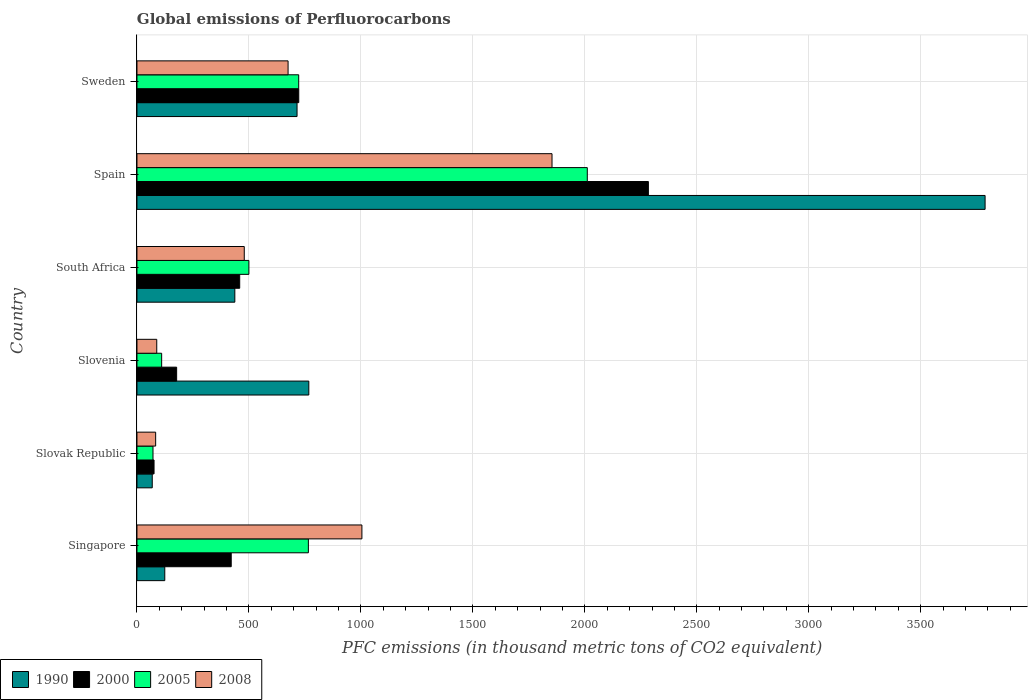How many groups of bars are there?
Give a very brief answer. 6. Are the number of bars per tick equal to the number of legend labels?
Make the answer very short. Yes. What is the global emissions of Perfluorocarbons in 2005 in Slovenia?
Ensure brevity in your answer.  110.3. Across all countries, what is the maximum global emissions of Perfluorocarbons in 2000?
Offer a terse response. 2283.8. Across all countries, what is the minimum global emissions of Perfluorocarbons in 2008?
Your answer should be compact. 83.5. In which country was the global emissions of Perfluorocarbons in 2008 maximum?
Offer a terse response. Spain. In which country was the global emissions of Perfluorocarbons in 1990 minimum?
Your answer should be very brief. Slovak Republic. What is the total global emissions of Perfluorocarbons in 2005 in the graph?
Ensure brevity in your answer.  4180.5. What is the difference between the global emissions of Perfluorocarbons in 1990 in Slovak Republic and that in South Africa?
Your response must be concise. -368.7. What is the difference between the global emissions of Perfluorocarbons in 1990 in Sweden and the global emissions of Perfluorocarbons in 2008 in South Africa?
Give a very brief answer. 235.7. What is the average global emissions of Perfluorocarbons in 2005 per country?
Provide a succinct answer. 696.75. What is the difference between the global emissions of Perfluorocarbons in 2008 and global emissions of Perfluorocarbons in 2000 in Sweden?
Make the answer very short. -47.7. What is the ratio of the global emissions of Perfluorocarbons in 2000 in Slovak Republic to that in Slovenia?
Offer a very short reply. 0.43. Is the difference between the global emissions of Perfluorocarbons in 2008 in Singapore and Slovak Republic greater than the difference between the global emissions of Perfluorocarbons in 2000 in Singapore and Slovak Republic?
Keep it short and to the point. Yes. What is the difference between the highest and the second highest global emissions of Perfluorocarbons in 2005?
Provide a succinct answer. 1245.5. What is the difference between the highest and the lowest global emissions of Perfluorocarbons in 1990?
Your response must be concise. 3719.1. What does the 2nd bar from the top in South Africa represents?
Provide a succinct answer. 2005. What does the 1st bar from the bottom in Singapore represents?
Your response must be concise. 1990. Are the values on the major ticks of X-axis written in scientific E-notation?
Ensure brevity in your answer.  No. Does the graph contain any zero values?
Provide a short and direct response. No. What is the title of the graph?
Your response must be concise. Global emissions of Perfluorocarbons. What is the label or title of the X-axis?
Offer a terse response. PFC emissions (in thousand metric tons of CO2 equivalent). What is the label or title of the Y-axis?
Your answer should be very brief. Country. What is the PFC emissions (in thousand metric tons of CO2 equivalent) of 1990 in Singapore?
Make the answer very short. 124.2. What is the PFC emissions (in thousand metric tons of CO2 equivalent) in 2000 in Singapore?
Keep it short and to the point. 420.9. What is the PFC emissions (in thousand metric tons of CO2 equivalent) of 2005 in Singapore?
Your answer should be compact. 765.5. What is the PFC emissions (in thousand metric tons of CO2 equivalent) of 2008 in Singapore?
Provide a succinct answer. 1004.5. What is the PFC emissions (in thousand metric tons of CO2 equivalent) of 1990 in Slovak Republic?
Your answer should be very brief. 68.3. What is the PFC emissions (in thousand metric tons of CO2 equivalent) in 2000 in Slovak Republic?
Your response must be concise. 76.3. What is the PFC emissions (in thousand metric tons of CO2 equivalent) of 2005 in Slovak Republic?
Your response must be concise. 71.6. What is the PFC emissions (in thousand metric tons of CO2 equivalent) in 2008 in Slovak Republic?
Your answer should be very brief. 83.5. What is the PFC emissions (in thousand metric tons of CO2 equivalent) of 1990 in Slovenia?
Provide a short and direct response. 767.4. What is the PFC emissions (in thousand metric tons of CO2 equivalent) in 2000 in Slovenia?
Your answer should be very brief. 177.2. What is the PFC emissions (in thousand metric tons of CO2 equivalent) of 2005 in Slovenia?
Your answer should be compact. 110.3. What is the PFC emissions (in thousand metric tons of CO2 equivalent) in 2008 in Slovenia?
Provide a short and direct response. 88.4. What is the PFC emissions (in thousand metric tons of CO2 equivalent) of 1990 in South Africa?
Ensure brevity in your answer.  437. What is the PFC emissions (in thousand metric tons of CO2 equivalent) in 2000 in South Africa?
Provide a short and direct response. 458.8. What is the PFC emissions (in thousand metric tons of CO2 equivalent) in 2005 in South Africa?
Make the answer very short. 499.8. What is the PFC emissions (in thousand metric tons of CO2 equivalent) in 2008 in South Africa?
Offer a terse response. 479.2. What is the PFC emissions (in thousand metric tons of CO2 equivalent) of 1990 in Spain?
Ensure brevity in your answer.  3787.4. What is the PFC emissions (in thousand metric tons of CO2 equivalent) of 2000 in Spain?
Keep it short and to the point. 2283.8. What is the PFC emissions (in thousand metric tons of CO2 equivalent) of 2005 in Spain?
Your answer should be compact. 2011. What is the PFC emissions (in thousand metric tons of CO2 equivalent) of 2008 in Spain?
Give a very brief answer. 1853.5. What is the PFC emissions (in thousand metric tons of CO2 equivalent) of 1990 in Sweden?
Keep it short and to the point. 714.9. What is the PFC emissions (in thousand metric tons of CO2 equivalent) in 2000 in Sweden?
Provide a short and direct response. 722.5. What is the PFC emissions (in thousand metric tons of CO2 equivalent) in 2005 in Sweden?
Ensure brevity in your answer.  722.3. What is the PFC emissions (in thousand metric tons of CO2 equivalent) in 2008 in Sweden?
Ensure brevity in your answer.  674.8. Across all countries, what is the maximum PFC emissions (in thousand metric tons of CO2 equivalent) in 1990?
Make the answer very short. 3787.4. Across all countries, what is the maximum PFC emissions (in thousand metric tons of CO2 equivalent) in 2000?
Offer a very short reply. 2283.8. Across all countries, what is the maximum PFC emissions (in thousand metric tons of CO2 equivalent) in 2005?
Make the answer very short. 2011. Across all countries, what is the maximum PFC emissions (in thousand metric tons of CO2 equivalent) of 2008?
Your answer should be very brief. 1853.5. Across all countries, what is the minimum PFC emissions (in thousand metric tons of CO2 equivalent) of 1990?
Your response must be concise. 68.3. Across all countries, what is the minimum PFC emissions (in thousand metric tons of CO2 equivalent) of 2000?
Make the answer very short. 76.3. Across all countries, what is the minimum PFC emissions (in thousand metric tons of CO2 equivalent) in 2005?
Give a very brief answer. 71.6. Across all countries, what is the minimum PFC emissions (in thousand metric tons of CO2 equivalent) in 2008?
Your response must be concise. 83.5. What is the total PFC emissions (in thousand metric tons of CO2 equivalent) of 1990 in the graph?
Ensure brevity in your answer.  5899.2. What is the total PFC emissions (in thousand metric tons of CO2 equivalent) of 2000 in the graph?
Make the answer very short. 4139.5. What is the total PFC emissions (in thousand metric tons of CO2 equivalent) in 2005 in the graph?
Your answer should be compact. 4180.5. What is the total PFC emissions (in thousand metric tons of CO2 equivalent) of 2008 in the graph?
Your answer should be very brief. 4183.9. What is the difference between the PFC emissions (in thousand metric tons of CO2 equivalent) in 1990 in Singapore and that in Slovak Republic?
Ensure brevity in your answer.  55.9. What is the difference between the PFC emissions (in thousand metric tons of CO2 equivalent) in 2000 in Singapore and that in Slovak Republic?
Offer a very short reply. 344.6. What is the difference between the PFC emissions (in thousand metric tons of CO2 equivalent) of 2005 in Singapore and that in Slovak Republic?
Provide a succinct answer. 693.9. What is the difference between the PFC emissions (in thousand metric tons of CO2 equivalent) of 2008 in Singapore and that in Slovak Republic?
Your answer should be compact. 921. What is the difference between the PFC emissions (in thousand metric tons of CO2 equivalent) of 1990 in Singapore and that in Slovenia?
Your answer should be compact. -643.2. What is the difference between the PFC emissions (in thousand metric tons of CO2 equivalent) of 2000 in Singapore and that in Slovenia?
Your response must be concise. 243.7. What is the difference between the PFC emissions (in thousand metric tons of CO2 equivalent) in 2005 in Singapore and that in Slovenia?
Make the answer very short. 655.2. What is the difference between the PFC emissions (in thousand metric tons of CO2 equivalent) of 2008 in Singapore and that in Slovenia?
Make the answer very short. 916.1. What is the difference between the PFC emissions (in thousand metric tons of CO2 equivalent) of 1990 in Singapore and that in South Africa?
Your response must be concise. -312.8. What is the difference between the PFC emissions (in thousand metric tons of CO2 equivalent) in 2000 in Singapore and that in South Africa?
Offer a terse response. -37.9. What is the difference between the PFC emissions (in thousand metric tons of CO2 equivalent) in 2005 in Singapore and that in South Africa?
Your response must be concise. 265.7. What is the difference between the PFC emissions (in thousand metric tons of CO2 equivalent) of 2008 in Singapore and that in South Africa?
Your answer should be very brief. 525.3. What is the difference between the PFC emissions (in thousand metric tons of CO2 equivalent) of 1990 in Singapore and that in Spain?
Give a very brief answer. -3663.2. What is the difference between the PFC emissions (in thousand metric tons of CO2 equivalent) of 2000 in Singapore and that in Spain?
Provide a short and direct response. -1862.9. What is the difference between the PFC emissions (in thousand metric tons of CO2 equivalent) of 2005 in Singapore and that in Spain?
Offer a terse response. -1245.5. What is the difference between the PFC emissions (in thousand metric tons of CO2 equivalent) in 2008 in Singapore and that in Spain?
Provide a succinct answer. -849. What is the difference between the PFC emissions (in thousand metric tons of CO2 equivalent) of 1990 in Singapore and that in Sweden?
Your answer should be compact. -590.7. What is the difference between the PFC emissions (in thousand metric tons of CO2 equivalent) in 2000 in Singapore and that in Sweden?
Offer a terse response. -301.6. What is the difference between the PFC emissions (in thousand metric tons of CO2 equivalent) in 2005 in Singapore and that in Sweden?
Ensure brevity in your answer.  43.2. What is the difference between the PFC emissions (in thousand metric tons of CO2 equivalent) of 2008 in Singapore and that in Sweden?
Provide a short and direct response. 329.7. What is the difference between the PFC emissions (in thousand metric tons of CO2 equivalent) of 1990 in Slovak Republic and that in Slovenia?
Make the answer very short. -699.1. What is the difference between the PFC emissions (in thousand metric tons of CO2 equivalent) of 2000 in Slovak Republic and that in Slovenia?
Your answer should be compact. -100.9. What is the difference between the PFC emissions (in thousand metric tons of CO2 equivalent) of 2005 in Slovak Republic and that in Slovenia?
Make the answer very short. -38.7. What is the difference between the PFC emissions (in thousand metric tons of CO2 equivalent) in 2008 in Slovak Republic and that in Slovenia?
Ensure brevity in your answer.  -4.9. What is the difference between the PFC emissions (in thousand metric tons of CO2 equivalent) of 1990 in Slovak Republic and that in South Africa?
Keep it short and to the point. -368.7. What is the difference between the PFC emissions (in thousand metric tons of CO2 equivalent) in 2000 in Slovak Republic and that in South Africa?
Make the answer very short. -382.5. What is the difference between the PFC emissions (in thousand metric tons of CO2 equivalent) in 2005 in Slovak Republic and that in South Africa?
Keep it short and to the point. -428.2. What is the difference between the PFC emissions (in thousand metric tons of CO2 equivalent) in 2008 in Slovak Republic and that in South Africa?
Provide a short and direct response. -395.7. What is the difference between the PFC emissions (in thousand metric tons of CO2 equivalent) in 1990 in Slovak Republic and that in Spain?
Offer a very short reply. -3719.1. What is the difference between the PFC emissions (in thousand metric tons of CO2 equivalent) of 2000 in Slovak Republic and that in Spain?
Keep it short and to the point. -2207.5. What is the difference between the PFC emissions (in thousand metric tons of CO2 equivalent) of 2005 in Slovak Republic and that in Spain?
Ensure brevity in your answer.  -1939.4. What is the difference between the PFC emissions (in thousand metric tons of CO2 equivalent) in 2008 in Slovak Republic and that in Spain?
Your answer should be compact. -1770. What is the difference between the PFC emissions (in thousand metric tons of CO2 equivalent) of 1990 in Slovak Republic and that in Sweden?
Provide a short and direct response. -646.6. What is the difference between the PFC emissions (in thousand metric tons of CO2 equivalent) in 2000 in Slovak Republic and that in Sweden?
Your answer should be compact. -646.2. What is the difference between the PFC emissions (in thousand metric tons of CO2 equivalent) of 2005 in Slovak Republic and that in Sweden?
Your answer should be very brief. -650.7. What is the difference between the PFC emissions (in thousand metric tons of CO2 equivalent) in 2008 in Slovak Republic and that in Sweden?
Provide a succinct answer. -591.3. What is the difference between the PFC emissions (in thousand metric tons of CO2 equivalent) of 1990 in Slovenia and that in South Africa?
Provide a short and direct response. 330.4. What is the difference between the PFC emissions (in thousand metric tons of CO2 equivalent) in 2000 in Slovenia and that in South Africa?
Make the answer very short. -281.6. What is the difference between the PFC emissions (in thousand metric tons of CO2 equivalent) of 2005 in Slovenia and that in South Africa?
Keep it short and to the point. -389.5. What is the difference between the PFC emissions (in thousand metric tons of CO2 equivalent) of 2008 in Slovenia and that in South Africa?
Offer a very short reply. -390.8. What is the difference between the PFC emissions (in thousand metric tons of CO2 equivalent) in 1990 in Slovenia and that in Spain?
Make the answer very short. -3020. What is the difference between the PFC emissions (in thousand metric tons of CO2 equivalent) in 2000 in Slovenia and that in Spain?
Your answer should be compact. -2106.6. What is the difference between the PFC emissions (in thousand metric tons of CO2 equivalent) of 2005 in Slovenia and that in Spain?
Your response must be concise. -1900.7. What is the difference between the PFC emissions (in thousand metric tons of CO2 equivalent) of 2008 in Slovenia and that in Spain?
Your response must be concise. -1765.1. What is the difference between the PFC emissions (in thousand metric tons of CO2 equivalent) of 1990 in Slovenia and that in Sweden?
Make the answer very short. 52.5. What is the difference between the PFC emissions (in thousand metric tons of CO2 equivalent) of 2000 in Slovenia and that in Sweden?
Offer a terse response. -545.3. What is the difference between the PFC emissions (in thousand metric tons of CO2 equivalent) in 2005 in Slovenia and that in Sweden?
Offer a very short reply. -612. What is the difference between the PFC emissions (in thousand metric tons of CO2 equivalent) of 2008 in Slovenia and that in Sweden?
Keep it short and to the point. -586.4. What is the difference between the PFC emissions (in thousand metric tons of CO2 equivalent) of 1990 in South Africa and that in Spain?
Keep it short and to the point. -3350.4. What is the difference between the PFC emissions (in thousand metric tons of CO2 equivalent) of 2000 in South Africa and that in Spain?
Offer a terse response. -1825. What is the difference between the PFC emissions (in thousand metric tons of CO2 equivalent) of 2005 in South Africa and that in Spain?
Ensure brevity in your answer.  -1511.2. What is the difference between the PFC emissions (in thousand metric tons of CO2 equivalent) of 2008 in South Africa and that in Spain?
Ensure brevity in your answer.  -1374.3. What is the difference between the PFC emissions (in thousand metric tons of CO2 equivalent) in 1990 in South Africa and that in Sweden?
Provide a short and direct response. -277.9. What is the difference between the PFC emissions (in thousand metric tons of CO2 equivalent) in 2000 in South Africa and that in Sweden?
Offer a very short reply. -263.7. What is the difference between the PFC emissions (in thousand metric tons of CO2 equivalent) of 2005 in South Africa and that in Sweden?
Provide a succinct answer. -222.5. What is the difference between the PFC emissions (in thousand metric tons of CO2 equivalent) of 2008 in South Africa and that in Sweden?
Provide a succinct answer. -195.6. What is the difference between the PFC emissions (in thousand metric tons of CO2 equivalent) in 1990 in Spain and that in Sweden?
Your answer should be compact. 3072.5. What is the difference between the PFC emissions (in thousand metric tons of CO2 equivalent) in 2000 in Spain and that in Sweden?
Provide a short and direct response. 1561.3. What is the difference between the PFC emissions (in thousand metric tons of CO2 equivalent) in 2005 in Spain and that in Sweden?
Your answer should be compact. 1288.7. What is the difference between the PFC emissions (in thousand metric tons of CO2 equivalent) of 2008 in Spain and that in Sweden?
Make the answer very short. 1178.7. What is the difference between the PFC emissions (in thousand metric tons of CO2 equivalent) of 1990 in Singapore and the PFC emissions (in thousand metric tons of CO2 equivalent) of 2000 in Slovak Republic?
Keep it short and to the point. 47.9. What is the difference between the PFC emissions (in thousand metric tons of CO2 equivalent) in 1990 in Singapore and the PFC emissions (in thousand metric tons of CO2 equivalent) in 2005 in Slovak Republic?
Offer a terse response. 52.6. What is the difference between the PFC emissions (in thousand metric tons of CO2 equivalent) of 1990 in Singapore and the PFC emissions (in thousand metric tons of CO2 equivalent) of 2008 in Slovak Republic?
Keep it short and to the point. 40.7. What is the difference between the PFC emissions (in thousand metric tons of CO2 equivalent) in 2000 in Singapore and the PFC emissions (in thousand metric tons of CO2 equivalent) in 2005 in Slovak Republic?
Provide a succinct answer. 349.3. What is the difference between the PFC emissions (in thousand metric tons of CO2 equivalent) in 2000 in Singapore and the PFC emissions (in thousand metric tons of CO2 equivalent) in 2008 in Slovak Republic?
Give a very brief answer. 337.4. What is the difference between the PFC emissions (in thousand metric tons of CO2 equivalent) of 2005 in Singapore and the PFC emissions (in thousand metric tons of CO2 equivalent) of 2008 in Slovak Republic?
Keep it short and to the point. 682. What is the difference between the PFC emissions (in thousand metric tons of CO2 equivalent) of 1990 in Singapore and the PFC emissions (in thousand metric tons of CO2 equivalent) of 2000 in Slovenia?
Provide a short and direct response. -53. What is the difference between the PFC emissions (in thousand metric tons of CO2 equivalent) in 1990 in Singapore and the PFC emissions (in thousand metric tons of CO2 equivalent) in 2005 in Slovenia?
Your answer should be compact. 13.9. What is the difference between the PFC emissions (in thousand metric tons of CO2 equivalent) in 1990 in Singapore and the PFC emissions (in thousand metric tons of CO2 equivalent) in 2008 in Slovenia?
Provide a short and direct response. 35.8. What is the difference between the PFC emissions (in thousand metric tons of CO2 equivalent) of 2000 in Singapore and the PFC emissions (in thousand metric tons of CO2 equivalent) of 2005 in Slovenia?
Provide a succinct answer. 310.6. What is the difference between the PFC emissions (in thousand metric tons of CO2 equivalent) of 2000 in Singapore and the PFC emissions (in thousand metric tons of CO2 equivalent) of 2008 in Slovenia?
Offer a terse response. 332.5. What is the difference between the PFC emissions (in thousand metric tons of CO2 equivalent) of 2005 in Singapore and the PFC emissions (in thousand metric tons of CO2 equivalent) of 2008 in Slovenia?
Make the answer very short. 677.1. What is the difference between the PFC emissions (in thousand metric tons of CO2 equivalent) in 1990 in Singapore and the PFC emissions (in thousand metric tons of CO2 equivalent) in 2000 in South Africa?
Provide a succinct answer. -334.6. What is the difference between the PFC emissions (in thousand metric tons of CO2 equivalent) in 1990 in Singapore and the PFC emissions (in thousand metric tons of CO2 equivalent) in 2005 in South Africa?
Keep it short and to the point. -375.6. What is the difference between the PFC emissions (in thousand metric tons of CO2 equivalent) in 1990 in Singapore and the PFC emissions (in thousand metric tons of CO2 equivalent) in 2008 in South Africa?
Keep it short and to the point. -355. What is the difference between the PFC emissions (in thousand metric tons of CO2 equivalent) in 2000 in Singapore and the PFC emissions (in thousand metric tons of CO2 equivalent) in 2005 in South Africa?
Keep it short and to the point. -78.9. What is the difference between the PFC emissions (in thousand metric tons of CO2 equivalent) of 2000 in Singapore and the PFC emissions (in thousand metric tons of CO2 equivalent) of 2008 in South Africa?
Your answer should be very brief. -58.3. What is the difference between the PFC emissions (in thousand metric tons of CO2 equivalent) in 2005 in Singapore and the PFC emissions (in thousand metric tons of CO2 equivalent) in 2008 in South Africa?
Your answer should be compact. 286.3. What is the difference between the PFC emissions (in thousand metric tons of CO2 equivalent) of 1990 in Singapore and the PFC emissions (in thousand metric tons of CO2 equivalent) of 2000 in Spain?
Your answer should be compact. -2159.6. What is the difference between the PFC emissions (in thousand metric tons of CO2 equivalent) in 1990 in Singapore and the PFC emissions (in thousand metric tons of CO2 equivalent) in 2005 in Spain?
Provide a succinct answer. -1886.8. What is the difference between the PFC emissions (in thousand metric tons of CO2 equivalent) of 1990 in Singapore and the PFC emissions (in thousand metric tons of CO2 equivalent) of 2008 in Spain?
Offer a terse response. -1729.3. What is the difference between the PFC emissions (in thousand metric tons of CO2 equivalent) of 2000 in Singapore and the PFC emissions (in thousand metric tons of CO2 equivalent) of 2005 in Spain?
Offer a very short reply. -1590.1. What is the difference between the PFC emissions (in thousand metric tons of CO2 equivalent) in 2000 in Singapore and the PFC emissions (in thousand metric tons of CO2 equivalent) in 2008 in Spain?
Provide a succinct answer. -1432.6. What is the difference between the PFC emissions (in thousand metric tons of CO2 equivalent) in 2005 in Singapore and the PFC emissions (in thousand metric tons of CO2 equivalent) in 2008 in Spain?
Make the answer very short. -1088. What is the difference between the PFC emissions (in thousand metric tons of CO2 equivalent) in 1990 in Singapore and the PFC emissions (in thousand metric tons of CO2 equivalent) in 2000 in Sweden?
Your answer should be very brief. -598.3. What is the difference between the PFC emissions (in thousand metric tons of CO2 equivalent) in 1990 in Singapore and the PFC emissions (in thousand metric tons of CO2 equivalent) in 2005 in Sweden?
Give a very brief answer. -598.1. What is the difference between the PFC emissions (in thousand metric tons of CO2 equivalent) in 1990 in Singapore and the PFC emissions (in thousand metric tons of CO2 equivalent) in 2008 in Sweden?
Provide a short and direct response. -550.6. What is the difference between the PFC emissions (in thousand metric tons of CO2 equivalent) of 2000 in Singapore and the PFC emissions (in thousand metric tons of CO2 equivalent) of 2005 in Sweden?
Ensure brevity in your answer.  -301.4. What is the difference between the PFC emissions (in thousand metric tons of CO2 equivalent) in 2000 in Singapore and the PFC emissions (in thousand metric tons of CO2 equivalent) in 2008 in Sweden?
Provide a short and direct response. -253.9. What is the difference between the PFC emissions (in thousand metric tons of CO2 equivalent) in 2005 in Singapore and the PFC emissions (in thousand metric tons of CO2 equivalent) in 2008 in Sweden?
Ensure brevity in your answer.  90.7. What is the difference between the PFC emissions (in thousand metric tons of CO2 equivalent) in 1990 in Slovak Republic and the PFC emissions (in thousand metric tons of CO2 equivalent) in 2000 in Slovenia?
Your response must be concise. -108.9. What is the difference between the PFC emissions (in thousand metric tons of CO2 equivalent) of 1990 in Slovak Republic and the PFC emissions (in thousand metric tons of CO2 equivalent) of 2005 in Slovenia?
Your response must be concise. -42. What is the difference between the PFC emissions (in thousand metric tons of CO2 equivalent) in 1990 in Slovak Republic and the PFC emissions (in thousand metric tons of CO2 equivalent) in 2008 in Slovenia?
Your answer should be very brief. -20.1. What is the difference between the PFC emissions (in thousand metric tons of CO2 equivalent) of 2000 in Slovak Republic and the PFC emissions (in thousand metric tons of CO2 equivalent) of 2005 in Slovenia?
Your answer should be very brief. -34. What is the difference between the PFC emissions (in thousand metric tons of CO2 equivalent) of 2005 in Slovak Republic and the PFC emissions (in thousand metric tons of CO2 equivalent) of 2008 in Slovenia?
Give a very brief answer. -16.8. What is the difference between the PFC emissions (in thousand metric tons of CO2 equivalent) in 1990 in Slovak Republic and the PFC emissions (in thousand metric tons of CO2 equivalent) in 2000 in South Africa?
Provide a succinct answer. -390.5. What is the difference between the PFC emissions (in thousand metric tons of CO2 equivalent) of 1990 in Slovak Republic and the PFC emissions (in thousand metric tons of CO2 equivalent) of 2005 in South Africa?
Keep it short and to the point. -431.5. What is the difference between the PFC emissions (in thousand metric tons of CO2 equivalent) in 1990 in Slovak Republic and the PFC emissions (in thousand metric tons of CO2 equivalent) in 2008 in South Africa?
Make the answer very short. -410.9. What is the difference between the PFC emissions (in thousand metric tons of CO2 equivalent) in 2000 in Slovak Republic and the PFC emissions (in thousand metric tons of CO2 equivalent) in 2005 in South Africa?
Provide a succinct answer. -423.5. What is the difference between the PFC emissions (in thousand metric tons of CO2 equivalent) of 2000 in Slovak Republic and the PFC emissions (in thousand metric tons of CO2 equivalent) of 2008 in South Africa?
Give a very brief answer. -402.9. What is the difference between the PFC emissions (in thousand metric tons of CO2 equivalent) of 2005 in Slovak Republic and the PFC emissions (in thousand metric tons of CO2 equivalent) of 2008 in South Africa?
Ensure brevity in your answer.  -407.6. What is the difference between the PFC emissions (in thousand metric tons of CO2 equivalent) in 1990 in Slovak Republic and the PFC emissions (in thousand metric tons of CO2 equivalent) in 2000 in Spain?
Offer a terse response. -2215.5. What is the difference between the PFC emissions (in thousand metric tons of CO2 equivalent) of 1990 in Slovak Republic and the PFC emissions (in thousand metric tons of CO2 equivalent) of 2005 in Spain?
Make the answer very short. -1942.7. What is the difference between the PFC emissions (in thousand metric tons of CO2 equivalent) of 1990 in Slovak Republic and the PFC emissions (in thousand metric tons of CO2 equivalent) of 2008 in Spain?
Give a very brief answer. -1785.2. What is the difference between the PFC emissions (in thousand metric tons of CO2 equivalent) in 2000 in Slovak Republic and the PFC emissions (in thousand metric tons of CO2 equivalent) in 2005 in Spain?
Make the answer very short. -1934.7. What is the difference between the PFC emissions (in thousand metric tons of CO2 equivalent) of 2000 in Slovak Republic and the PFC emissions (in thousand metric tons of CO2 equivalent) of 2008 in Spain?
Provide a short and direct response. -1777.2. What is the difference between the PFC emissions (in thousand metric tons of CO2 equivalent) in 2005 in Slovak Republic and the PFC emissions (in thousand metric tons of CO2 equivalent) in 2008 in Spain?
Your response must be concise. -1781.9. What is the difference between the PFC emissions (in thousand metric tons of CO2 equivalent) in 1990 in Slovak Republic and the PFC emissions (in thousand metric tons of CO2 equivalent) in 2000 in Sweden?
Offer a very short reply. -654.2. What is the difference between the PFC emissions (in thousand metric tons of CO2 equivalent) of 1990 in Slovak Republic and the PFC emissions (in thousand metric tons of CO2 equivalent) of 2005 in Sweden?
Provide a succinct answer. -654. What is the difference between the PFC emissions (in thousand metric tons of CO2 equivalent) of 1990 in Slovak Republic and the PFC emissions (in thousand metric tons of CO2 equivalent) of 2008 in Sweden?
Give a very brief answer. -606.5. What is the difference between the PFC emissions (in thousand metric tons of CO2 equivalent) of 2000 in Slovak Republic and the PFC emissions (in thousand metric tons of CO2 equivalent) of 2005 in Sweden?
Offer a very short reply. -646. What is the difference between the PFC emissions (in thousand metric tons of CO2 equivalent) in 2000 in Slovak Republic and the PFC emissions (in thousand metric tons of CO2 equivalent) in 2008 in Sweden?
Your answer should be compact. -598.5. What is the difference between the PFC emissions (in thousand metric tons of CO2 equivalent) in 2005 in Slovak Republic and the PFC emissions (in thousand metric tons of CO2 equivalent) in 2008 in Sweden?
Give a very brief answer. -603.2. What is the difference between the PFC emissions (in thousand metric tons of CO2 equivalent) in 1990 in Slovenia and the PFC emissions (in thousand metric tons of CO2 equivalent) in 2000 in South Africa?
Ensure brevity in your answer.  308.6. What is the difference between the PFC emissions (in thousand metric tons of CO2 equivalent) of 1990 in Slovenia and the PFC emissions (in thousand metric tons of CO2 equivalent) of 2005 in South Africa?
Keep it short and to the point. 267.6. What is the difference between the PFC emissions (in thousand metric tons of CO2 equivalent) in 1990 in Slovenia and the PFC emissions (in thousand metric tons of CO2 equivalent) in 2008 in South Africa?
Give a very brief answer. 288.2. What is the difference between the PFC emissions (in thousand metric tons of CO2 equivalent) of 2000 in Slovenia and the PFC emissions (in thousand metric tons of CO2 equivalent) of 2005 in South Africa?
Offer a terse response. -322.6. What is the difference between the PFC emissions (in thousand metric tons of CO2 equivalent) in 2000 in Slovenia and the PFC emissions (in thousand metric tons of CO2 equivalent) in 2008 in South Africa?
Keep it short and to the point. -302. What is the difference between the PFC emissions (in thousand metric tons of CO2 equivalent) of 2005 in Slovenia and the PFC emissions (in thousand metric tons of CO2 equivalent) of 2008 in South Africa?
Your response must be concise. -368.9. What is the difference between the PFC emissions (in thousand metric tons of CO2 equivalent) in 1990 in Slovenia and the PFC emissions (in thousand metric tons of CO2 equivalent) in 2000 in Spain?
Provide a short and direct response. -1516.4. What is the difference between the PFC emissions (in thousand metric tons of CO2 equivalent) of 1990 in Slovenia and the PFC emissions (in thousand metric tons of CO2 equivalent) of 2005 in Spain?
Your answer should be very brief. -1243.6. What is the difference between the PFC emissions (in thousand metric tons of CO2 equivalent) of 1990 in Slovenia and the PFC emissions (in thousand metric tons of CO2 equivalent) of 2008 in Spain?
Your response must be concise. -1086.1. What is the difference between the PFC emissions (in thousand metric tons of CO2 equivalent) of 2000 in Slovenia and the PFC emissions (in thousand metric tons of CO2 equivalent) of 2005 in Spain?
Your response must be concise. -1833.8. What is the difference between the PFC emissions (in thousand metric tons of CO2 equivalent) in 2000 in Slovenia and the PFC emissions (in thousand metric tons of CO2 equivalent) in 2008 in Spain?
Offer a terse response. -1676.3. What is the difference between the PFC emissions (in thousand metric tons of CO2 equivalent) of 2005 in Slovenia and the PFC emissions (in thousand metric tons of CO2 equivalent) of 2008 in Spain?
Provide a short and direct response. -1743.2. What is the difference between the PFC emissions (in thousand metric tons of CO2 equivalent) of 1990 in Slovenia and the PFC emissions (in thousand metric tons of CO2 equivalent) of 2000 in Sweden?
Give a very brief answer. 44.9. What is the difference between the PFC emissions (in thousand metric tons of CO2 equivalent) in 1990 in Slovenia and the PFC emissions (in thousand metric tons of CO2 equivalent) in 2005 in Sweden?
Give a very brief answer. 45.1. What is the difference between the PFC emissions (in thousand metric tons of CO2 equivalent) of 1990 in Slovenia and the PFC emissions (in thousand metric tons of CO2 equivalent) of 2008 in Sweden?
Offer a very short reply. 92.6. What is the difference between the PFC emissions (in thousand metric tons of CO2 equivalent) of 2000 in Slovenia and the PFC emissions (in thousand metric tons of CO2 equivalent) of 2005 in Sweden?
Offer a terse response. -545.1. What is the difference between the PFC emissions (in thousand metric tons of CO2 equivalent) of 2000 in Slovenia and the PFC emissions (in thousand metric tons of CO2 equivalent) of 2008 in Sweden?
Make the answer very short. -497.6. What is the difference between the PFC emissions (in thousand metric tons of CO2 equivalent) in 2005 in Slovenia and the PFC emissions (in thousand metric tons of CO2 equivalent) in 2008 in Sweden?
Provide a short and direct response. -564.5. What is the difference between the PFC emissions (in thousand metric tons of CO2 equivalent) of 1990 in South Africa and the PFC emissions (in thousand metric tons of CO2 equivalent) of 2000 in Spain?
Offer a terse response. -1846.8. What is the difference between the PFC emissions (in thousand metric tons of CO2 equivalent) in 1990 in South Africa and the PFC emissions (in thousand metric tons of CO2 equivalent) in 2005 in Spain?
Your response must be concise. -1574. What is the difference between the PFC emissions (in thousand metric tons of CO2 equivalent) in 1990 in South Africa and the PFC emissions (in thousand metric tons of CO2 equivalent) in 2008 in Spain?
Offer a very short reply. -1416.5. What is the difference between the PFC emissions (in thousand metric tons of CO2 equivalent) in 2000 in South Africa and the PFC emissions (in thousand metric tons of CO2 equivalent) in 2005 in Spain?
Provide a succinct answer. -1552.2. What is the difference between the PFC emissions (in thousand metric tons of CO2 equivalent) of 2000 in South Africa and the PFC emissions (in thousand metric tons of CO2 equivalent) of 2008 in Spain?
Provide a succinct answer. -1394.7. What is the difference between the PFC emissions (in thousand metric tons of CO2 equivalent) of 2005 in South Africa and the PFC emissions (in thousand metric tons of CO2 equivalent) of 2008 in Spain?
Ensure brevity in your answer.  -1353.7. What is the difference between the PFC emissions (in thousand metric tons of CO2 equivalent) in 1990 in South Africa and the PFC emissions (in thousand metric tons of CO2 equivalent) in 2000 in Sweden?
Your response must be concise. -285.5. What is the difference between the PFC emissions (in thousand metric tons of CO2 equivalent) in 1990 in South Africa and the PFC emissions (in thousand metric tons of CO2 equivalent) in 2005 in Sweden?
Offer a terse response. -285.3. What is the difference between the PFC emissions (in thousand metric tons of CO2 equivalent) in 1990 in South Africa and the PFC emissions (in thousand metric tons of CO2 equivalent) in 2008 in Sweden?
Offer a very short reply. -237.8. What is the difference between the PFC emissions (in thousand metric tons of CO2 equivalent) of 2000 in South Africa and the PFC emissions (in thousand metric tons of CO2 equivalent) of 2005 in Sweden?
Offer a very short reply. -263.5. What is the difference between the PFC emissions (in thousand metric tons of CO2 equivalent) of 2000 in South Africa and the PFC emissions (in thousand metric tons of CO2 equivalent) of 2008 in Sweden?
Give a very brief answer. -216. What is the difference between the PFC emissions (in thousand metric tons of CO2 equivalent) in 2005 in South Africa and the PFC emissions (in thousand metric tons of CO2 equivalent) in 2008 in Sweden?
Provide a short and direct response. -175. What is the difference between the PFC emissions (in thousand metric tons of CO2 equivalent) in 1990 in Spain and the PFC emissions (in thousand metric tons of CO2 equivalent) in 2000 in Sweden?
Your answer should be compact. 3064.9. What is the difference between the PFC emissions (in thousand metric tons of CO2 equivalent) of 1990 in Spain and the PFC emissions (in thousand metric tons of CO2 equivalent) of 2005 in Sweden?
Provide a succinct answer. 3065.1. What is the difference between the PFC emissions (in thousand metric tons of CO2 equivalent) in 1990 in Spain and the PFC emissions (in thousand metric tons of CO2 equivalent) in 2008 in Sweden?
Offer a very short reply. 3112.6. What is the difference between the PFC emissions (in thousand metric tons of CO2 equivalent) in 2000 in Spain and the PFC emissions (in thousand metric tons of CO2 equivalent) in 2005 in Sweden?
Your response must be concise. 1561.5. What is the difference between the PFC emissions (in thousand metric tons of CO2 equivalent) of 2000 in Spain and the PFC emissions (in thousand metric tons of CO2 equivalent) of 2008 in Sweden?
Your answer should be compact. 1609. What is the difference between the PFC emissions (in thousand metric tons of CO2 equivalent) in 2005 in Spain and the PFC emissions (in thousand metric tons of CO2 equivalent) in 2008 in Sweden?
Ensure brevity in your answer.  1336.2. What is the average PFC emissions (in thousand metric tons of CO2 equivalent) of 1990 per country?
Offer a terse response. 983.2. What is the average PFC emissions (in thousand metric tons of CO2 equivalent) in 2000 per country?
Your answer should be very brief. 689.92. What is the average PFC emissions (in thousand metric tons of CO2 equivalent) in 2005 per country?
Offer a terse response. 696.75. What is the average PFC emissions (in thousand metric tons of CO2 equivalent) in 2008 per country?
Your answer should be compact. 697.32. What is the difference between the PFC emissions (in thousand metric tons of CO2 equivalent) in 1990 and PFC emissions (in thousand metric tons of CO2 equivalent) in 2000 in Singapore?
Provide a succinct answer. -296.7. What is the difference between the PFC emissions (in thousand metric tons of CO2 equivalent) of 1990 and PFC emissions (in thousand metric tons of CO2 equivalent) of 2005 in Singapore?
Give a very brief answer. -641.3. What is the difference between the PFC emissions (in thousand metric tons of CO2 equivalent) in 1990 and PFC emissions (in thousand metric tons of CO2 equivalent) in 2008 in Singapore?
Your answer should be compact. -880.3. What is the difference between the PFC emissions (in thousand metric tons of CO2 equivalent) of 2000 and PFC emissions (in thousand metric tons of CO2 equivalent) of 2005 in Singapore?
Your response must be concise. -344.6. What is the difference between the PFC emissions (in thousand metric tons of CO2 equivalent) of 2000 and PFC emissions (in thousand metric tons of CO2 equivalent) of 2008 in Singapore?
Offer a terse response. -583.6. What is the difference between the PFC emissions (in thousand metric tons of CO2 equivalent) of 2005 and PFC emissions (in thousand metric tons of CO2 equivalent) of 2008 in Singapore?
Provide a succinct answer. -239. What is the difference between the PFC emissions (in thousand metric tons of CO2 equivalent) in 1990 and PFC emissions (in thousand metric tons of CO2 equivalent) in 2005 in Slovak Republic?
Provide a short and direct response. -3.3. What is the difference between the PFC emissions (in thousand metric tons of CO2 equivalent) in 1990 and PFC emissions (in thousand metric tons of CO2 equivalent) in 2008 in Slovak Republic?
Your answer should be very brief. -15.2. What is the difference between the PFC emissions (in thousand metric tons of CO2 equivalent) of 2005 and PFC emissions (in thousand metric tons of CO2 equivalent) of 2008 in Slovak Republic?
Ensure brevity in your answer.  -11.9. What is the difference between the PFC emissions (in thousand metric tons of CO2 equivalent) of 1990 and PFC emissions (in thousand metric tons of CO2 equivalent) of 2000 in Slovenia?
Your answer should be compact. 590.2. What is the difference between the PFC emissions (in thousand metric tons of CO2 equivalent) in 1990 and PFC emissions (in thousand metric tons of CO2 equivalent) in 2005 in Slovenia?
Your response must be concise. 657.1. What is the difference between the PFC emissions (in thousand metric tons of CO2 equivalent) of 1990 and PFC emissions (in thousand metric tons of CO2 equivalent) of 2008 in Slovenia?
Your answer should be very brief. 679. What is the difference between the PFC emissions (in thousand metric tons of CO2 equivalent) of 2000 and PFC emissions (in thousand metric tons of CO2 equivalent) of 2005 in Slovenia?
Provide a succinct answer. 66.9. What is the difference between the PFC emissions (in thousand metric tons of CO2 equivalent) in 2000 and PFC emissions (in thousand metric tons of CO2 equivalent) in 2008 in Slovenia?
Ensure brevity in your answer.  88.8. What is the difference between the PFC emissions (in thousand metric tons of CO2 equivalent) of 2005 and PFC emissions (in thousand metric tons of CO2 equivalent) of 2008 in Slovenia?
Provide a short and direct response. 21.9. What is the difference between the PFC emissions (in thousand metric tons of CO2 equivalent) of 1990 and PFC emissions (in thousand metric tons of CO2 equivalent) of 2000 in South Africa?
Keep it short and to the point. -21.8. What is the difference between the PFC emissions (in thousand metric tons of CO2 equivalent) of 1990 and PFC emissions (in thousand metric tons of CO2 equivalent) of 2005 in South Africa?
Ensure brevity in your answer.  -62.8. What is the difference between the PFC emissions (in thousand metric tons of CO2 equivalent) in 1990 and PFC emissions (in thousand metric tons of CO2 equivalent) in 2008 in South Africa?
Provide a succinct answer. -42.2. What is the difference between the PFC emissions (in thousand metric tons of CO2 equivalent) in 2000 and PFC emissions (in thousand metric tons of CO2 equivalent) in 2005 in South Africa?
Offer a terse response. -41. What is the difference between the PFC emissions (in thousand metric tons of CO2 equivalent) in 2000 and PFC emissions (in thousand metric tons of CO2 equivalent) in 2008 in South Africa?
Give a very brief answer. -20.4. What is the difference between the PFC emissions (in thousand metric tons of CO2 equivalent) of 2005 and PFC emissions (in thousand metric tons of CO2 equivalent) of 2008 in South Africa?
Your answer should be compact. 20.6. What is the difference between the PFC emissions (in thousand metric tons of CO2 equivalent) of 1990 and PFC emissions (in thousand metric tons of CO2 equivalent) of 2000 in Spain?
Your response must be concise. 1503.6. What is the difference between the PFC emissions (in thousand metric tons of CO2 equivalent) in 1990 and PFC emissions (in thousand metric tons of CO2 equivalent) in 2005 in Spain?
Provide a short and direct response. 1776.4. What is the difference between the PFC emissions (in thousand metric tons of CO2 equivalent) of 1990 and PFC emissions (in thousand metric tons of CO2 equivalent) of 2008 in Spain?
Offer a terse response. 1933.9. What is the difference between the PFC emissions (in thousand metric tons of CO2 equivalent) in 2000 and PFC emissions (in thousand metric tons of CO2 equivalent) in 2005 in Spain?
Your answer should be very brief. 272.8. What is the difference between the PFC emissions (in thousand metric tons of CO2 equivalent) of 2000 and PFC emissions (in thousand metric tons of CO2 equivalent) of 2008 in Spain?
Make the answer very short. 430.3. What is the difference between the PFC emissions (in thousand metric tons of CO2 equivalent) in 2005 and PFC emissions (in thousand metric tons of CO2 equivalent) in 2008 in Spain?
Ensure brevity in your answer.  157.5. What is the difference between the PFC emissions (in thousand metric tons of CO2 equivalent) of 1990 and PFC emissions (in thousand metric tons of CO2 equivalent) of 2000 in Sweden?
Provide a succinct answer. -7.6. What is the difference between the PFC emissions (in thousand metric tons of CO2 equivalent) of 1990 and PFC emissions (in thousand metric tons of CO2 equivalent) of 2008 in Sweden?
Offer a terse response. 40.1. What is the difference between the PFC emissions (in thousand metric tons of CO2 equivalent) of 2000 and PFC emissions (in thousand metric tons of CO2 equivalent) of 2005 in Sweden?
Offer a terse response. 0.2. What is the difference between the PFC emissions (in thousand metric tons of CO2 equivalent) in 2000 and PFC emissions (in thousand metric tons of CO2 equivalent) in 2008 in Sweden?
Make the answer very short. 47.7. What is the difference between the PFC emissions (in thousand metric tons of CO2 equivalent) of 2005 and PFC emissions (in thousand metric tons of CO2 equivalent) of 2008 in Sweden?
Provide a short and direct response. 47.5. What is the ratio of the PFC emissions (in thousand metric tons of CO2 equivalent) in 1990 in Singapore to that in Slovak Republic?
Give a very brief answer. 1.82. What is the ratio of the PFC emissions (in thousand metric tons of CO2 equivalent) in 2000 in Singapore to that in Slovak Republic?
Give a very brief answer. 5.52. What is the ratio of the PFC emissions (in thousand metric tons of CO2 equivalent) of 2005 in Singapore to that in Slovak Republic?
Offer a very short reply. 10.69. What is the ratio of the PFC emissions (in thousand metric tons of CO2 equivalent) of 2008 in Singapore to that in Slovak Republic?
Give a very brief answer. 12.03. What is the ratio of the PFC emissions (in thousand metric tons of CO2 equivalent) of 1990 in Singapore to that in Slovenia?
Offer a terse response. 0.16. What is the ratio of the PFC emissions (in thousand metric tons of CO2 equivalent) in 2000 in Singapore to that in Slovenia?
Ensure brevity in your answer.  2.38. What is the ratio of the PFC emissions (in thousand metric tons of CO2 equivalent) in 2005 in Singapore to that in Slovenia?
Provide a short and direct response. 6.94. What is the ratio of the PFC emissions (in thousand metric tons of CO2 equivalent) in 2008 in Singapore to that in Slovenia?
Offer a very short reply. 11.36. What is the ratio of the PFC emissions (in thousand metric tons of CO2 equivalent) in 1990 in Singapore to that in South Africa?
Give a very brief answer. 0.28. What is the ratio of the PFC emissions (in thousand metric tons of CO2 equivalent) in 2000 in Singapore to that in South Africa?
Give a very brief answer. 0.92. What is the ratio of the PFC emissions (in thousand metric tons of CO2 equivalent) of 2005 in Singapore to that in South Africa?
Your response must be concise. 1.53. What is the ratio of the PFC emissions (in thousand metric tons of CO2 equivalent) of 2008 in Singapore to that in South Africa?
Offer a terse response. 2.1. What is the ratio of the PFC emissions (in thousand metric tons of CO2 equivalent) in 1990 in Singapore to that in Spain?
Offer a terse response. 0.03. What is the ratio of the PFC emissions (in thousand metric tons of CO2 equivalent) of 2000 in Singapore to that in Spain?
Provide a succinct answer. 0.18. What is the ratio of the PFC emissions (in thousand metric tons of CO2 equivalent) of 2005 in Singapore to that in Spain?
Keep it short and to the point. 0.38. What is the ratio of the PFC emissions (in thousand metric tons of CO2 equivalent) in 2008 in Singapore to that in Spain?
Provide a succinct answer. 0.54. What is the ratio of the PFC emissions (in thousand metric tons of CO2 equivalent) of 1990 in Singapore to that in Sweden?
Ensure brevity in your answer.  0.17. What is the ratio of the PFC emissions (in thousand metric tons of CO2 equivalent) in 2000 in Singapore to that in Sweden?
Provide a short and direct response. 0.58. What is the ratio of the PFC emissions (in thousand metric tons of CO2 equivalent) in 2005 in Singapore to that in Sweden?
Keep it short and to the point. 1.06. What is the ratio of the PFC emissions (in thousand metric tons of CO2 equivalent) in 2008 in Singapore to that in Sweden?
Give a very brief answer. 1.49. What is the ratio of the PFC emissions (in thousand metric tons of CO2 equivalent) in 1990 in Slovak Republic to that in Slovenia?
Your response must be concise. 0.09. What is the ratio of the PFC emissions (in thousand metric tons of CO2 equivalent) in 2000 in Slovak Republic to that in Slovenia?
Your response must be concise. 0.43. What is the ratio of the PFC emissions (in thousand metric tons of CO2 equivalent) in 2005 in Slovak Republic to that in Slovenia?
Provide a short and direct response. 0.65. What is the ratio of the PFC emissions (in thousand metric tons of CO2 equivalent) of 2008 in Slovak Republic to that in Slovenia?
Make the answer very short. 0.94. What is the ratio of the PFC emissions (in thousand metric tons of CO2 equivalent) in 1990 in Slovak Republic to that in South Africa?
Make the answer very short. 0.16. What is the ratio of the PFC emissions (in thousand metric tons of CO2 equivalent) in 2000 in Slovak Republic to that in South Africa?
Your answer should be very brief. 0.17. What is the ratio of the PFC emissions (in thousand metric tons of CO2 equivalent) in 2005 in Slovak Republic to that in South Africa?
Provide a short and direct response. 0.14. What is the ratio of the PFC emissions (in thousand metric tons of CO2 equivalent) of 2008 in Slovak Republic to that in South Africa?
Give a very brief answer. 0.17. What is the ratio of the PFC emissions (in thousand metric tons of CO2 equivalent) in 1990 in Slovak Republic to that in Spain?
Offer a very short reply. 0.02. What is the ratio of the PFC emissions (in thousand metric tons of CO2 equivalent) in 2000 in Slovak Republic to that in Spain?
Make the answer very short. 0.03. What is the ratio of the PFC emissions (in thousand metric tons of CO2 equivalent) in 2005 in Slovak Republic to that in Spain?
Offer a terse response. 0.04. What is the ratio of the PFC emissions (in thousand metric tons of CO2 equivalent) of 2008 in Slovak Republic to that in Spain?
Your response must be concise. 0.04. What is the ratio of the PFC emissions (in thousand metric tons of CO2 equivalent) of 1990 in Slovak Republic to that in Sweden?
Your answer should be compact. 0.1. What is the ratio of the PFC emissions (in thousand metric tons of CO2 equivalent) in 2000 in Slovak Republic to that in Sweden?
Ensure brevity in your answer.  0.11. What is the ratio of the PFC emissions (in thousand metric tons of CO2 equivalent) of 2005 in Slovak Republic to that in Sweden?
Make the answer very short. 0.1. What is the ratio of the PFC emissions (in thousand metric tons of CO2 equivalent) in 2008 in Slovak Republic to that in Sweden?
Offer a terse response. 0.12. What is the ratio of the PFC emissions (in thousand metric tons of CO2 equivalent) of 1990 in Slovenia to that in South Africa?
Offer a very short reply. 1.76. What is the ratio of the PFC emissions (in thousand metric tons of CO2 equivalent) of 2000 in Slovenia to that in South Africa?
Provide a succinct answer. 0.39. What is the ratio of the PFC emissions (in thousand metric tons of CO2 equivalent) of 2005 in Slovenia to that in South Africa?
Offer a very short reply. 0.22. What is the ratio of the PFC emissions (in thousand metric tons of CO2 equivalent) of 2008 in Slovenia to that in South Africa?
Your answer should be very brief. 0.18. What is the ratio of the PFC emissions (in thousand metric tons of CO2 equivalent) of 1990 in Slovenia to that in Spain?
Offer a very short reply. 0.2. What is the ratio of the PFC emissions (in thousand metric tons of CO2 equivalent) of 2000 in Slovenia to that in Spain?
Your answer should be compact. 0.08. What is the ratio of the PFC emissions (in thousand metric tons of CO2 equivalent) in 2005 in Slovenia to that in Spain?
Ensure brevity in your answer.  0.05. What is the ratio of the PFC emissions (in thousand metric tons of CO2 equivalent) in 2008 in Slovenia to that in Spain?
Your answer should be compact. 0.05. What is the ratio of the PFC emissions (in thousand metric tons of CO2 equivalent) in 1990 in Slovenia to that in Sweden?
Give a very brief answer. 1.07. What is the ratio of the PFC emissions (in thousand metric tons of CO2 equivalent) in 2000 in Slovenia to that in Sweden?
Ensure brevity in your answer.  0.25. What is the ratio of the PFC emissions (in thousand metric tons of CO2 equivalent) of 2005 in Slovenia to that in Sweden?
Ensure brevity in your answer.  0.15. What is the ratio of the PFC emissions (in thousand metric tons of CO2 equivalent) of 2008 in Slovenia to that in Sweden?
Your response must be concise. 0.13. What is the ratio of the PFC emissions (in thousand metric tons of CO2 equivalent) of 1990 in South Africa to that in Spain?
Your response must be concise. 0.12. What is the ratio of the PFC emissions (in thousand metric tons of CO2 equivalent) of 2000 in South Africa to that in Spain?
Keep it short and to the point. 0.2. What is the ratio of the PFC emissions (in thousand metric tons of CO2 equivalent) in 2005 in South Africa to that in Spain?
Provide a short and direct response. 0.25. What is the ratio of the PFC emissions (in thousand metric tons of CO2 equivalent) of 2008 in South Africa to that in Spain?
Your answer should be very brief. 0.26. What is the ratio of the PFC emissions (in thousand metric tons of CO2 equivalent) of 1990 in South Africa to that in Sweden?
Your answer should be very brief. 0.61. What is the ratio of the PFC emissions (in thousand metric tons of CO2 equivalent) of 2000 in South Africa to that in Sweden?
Your answer should be very brief. 0.64. What is the ratio of the PFC emissions (in thousand metric tons of CO2 equivalent) of 2005 in South Africa to that in Sweden?
Ensure brevity in your answer.  0.69. What is the ratio of the PFC emissions (in thousand metric tons of CO2 equivalent) of 2008 in South Africa to that in Sweden?
Offer a very short reply. 0.71. What is the ratio of the PFC emissions (in thousand metric tons of CO2 equivalent) of 1990 in Spain to that in Sweden?
Offer a terse response. 5.3. What is the ratio of the PFC emissions (in thousand metric tons of CO2 equivalent) of 2000 in Spain to that in Sweden?
Your response must be concise. 3.16. What is the ratio of the PFC emissions (in thousand metric tons of CO2 equivalent) of 2005 in Spain to that in Sweden?
Your response must be concise. 2.78. What is the ratio of the PFC emissions (in thousand metric tons of CO2 equivalent) of 2008 in Spain to that in Sweden?
Make the answer very short. 2.75. What is the difference between the highest and the second highest PFC emissions (in thousand metric tons of CO2 equivalent) of 1990?
Your response must be concise. 3020. What is the difference between the highest and the second highest PFC emissions (in thousand metric tons of CO2 equivalent) of 2000?
Your answer should be very brief. 1561.3. What is the difference between the highest and the second highest PFC emissions (in thousand metric tons of CO2 equivalent) of 2005?
Provide a succinct answer. 1245.5. What is the difference between the highest and the second highest PFC emissions (in thousand metric tons of CO2 equivalent) in 2008?
Provide a succinct answer. 849. What is the difference between the highest and the lowest PFC emissions (in thousand metric tons of CO2 equivalent) in 1990?
Your answer should be very brief. 3719.1. What is the difference between the highest and the lowest PFC emissions (in thousand metric tons of CO2 equivalent) in 2000?
Offer a terse response. 2207.5. What is the difference between the highest and the lowest PFC emissions (in thousand metric tons of CO2 equivalent) of 2005?
Provide a succinct answer. 1939.4. What is the difference between the highest and the lowest PFC emissions (in thousand metric tons of CO2 equivalent) of 2008?
Provide a short and direct response. 1770. 